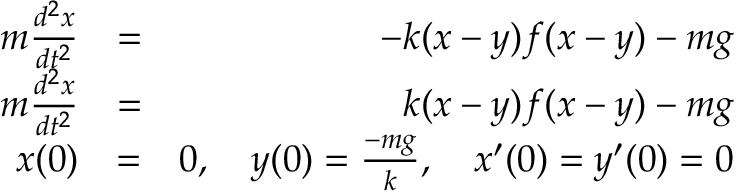<formula> <loc_0><loc_0><loc_500><loc_500>\begin{array} { r l r } { m \frac { d ^ { 2 } x } { d t ^ { 2 } } } & { = } & { - k ( x - y ) f ( x - y ) - m g } \\ { m \frac { d ^ { 2 } x } { d t ^ { 2 } } } & { = } & { k ( x - y ) f ( x - y ) - m g } \\ { x ( 0 ) } & { = } & { 0 , \quad y ( 0 ) = \frac { - m g } { k } , \quad x ^ { \prime } ( 0 ) = y ^ { \prime } ( 0 ) = 0 } \end{array}</formula> 